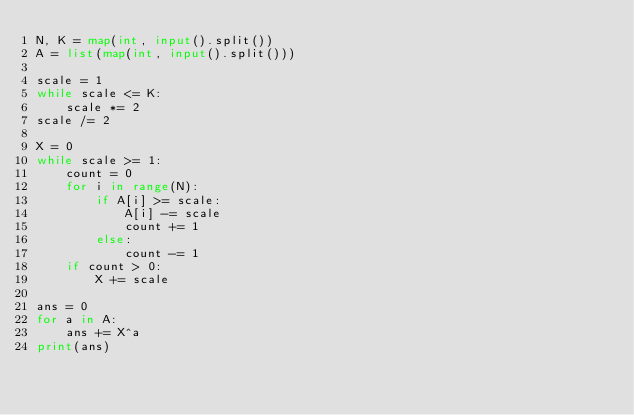<code> <loc_0><loc_0><loc_500><loc_500><_Python_>N, K = map(int, input().split())
A = list(map(int, input().split()))

scale = 1
while scale <= K:
    scale *= 2
scale /= 2

X = 0
while scale >= 1:
    count = 0
    for i in range(N):
        if A[i] >= scale:
            A[i] -= scale
            count += 1
        else:
            count -= 1
    if count > 0:
        X += scale

ans = 0
for a in A:
    ans += X^a
print(ans)
</code> 